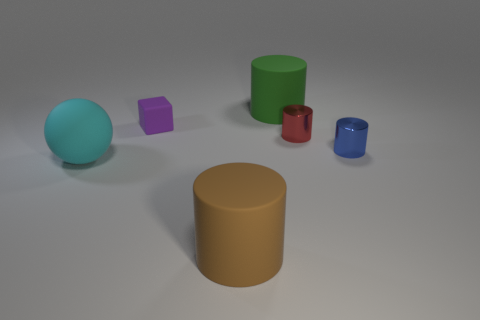What number of metal things are red objects or red blocks?
Make the answer very short. 1. The large thing that is behind the brown cylinder and in front of the small purple object is made of what material?
Offer a very short reply. Rubber. There is a large matte cylinder behind the large cylinder in front of the blue metallic thing; are there any cyan matte objects left of it?
Your answer should be compact. Yes. What is the shape of the small red object that is made of the same material as the small blue cylinder?
Offer a very short reply. Cylinder. Are there fewer cylinders left of the big green object than blocks in front of the cyan thing?
Ensure brevity in your answer.  No. What number of tiny things are either cyan matte spheres or gray matte cylinders?
Provide a succinct answer. 0. There is a small metallic object in front of the red shiny cylinder; is it the same shape as the small purple thing that is to the left of the brown rubber thing?
Keep it short and to the point. No. What is the size of the matte thing right of the large cylinder in front of the tiny purple rubber object that is on the left side of the red cylinder?
Offer a very short reply. Large. There is a thing that is behind the purple thing; how big is it?
Ensure brevity in your answer.  Large. There is a cylinder that is to the right of the red cylinder; what is it made of?
Ensure brevity in your answer.  Metal. 